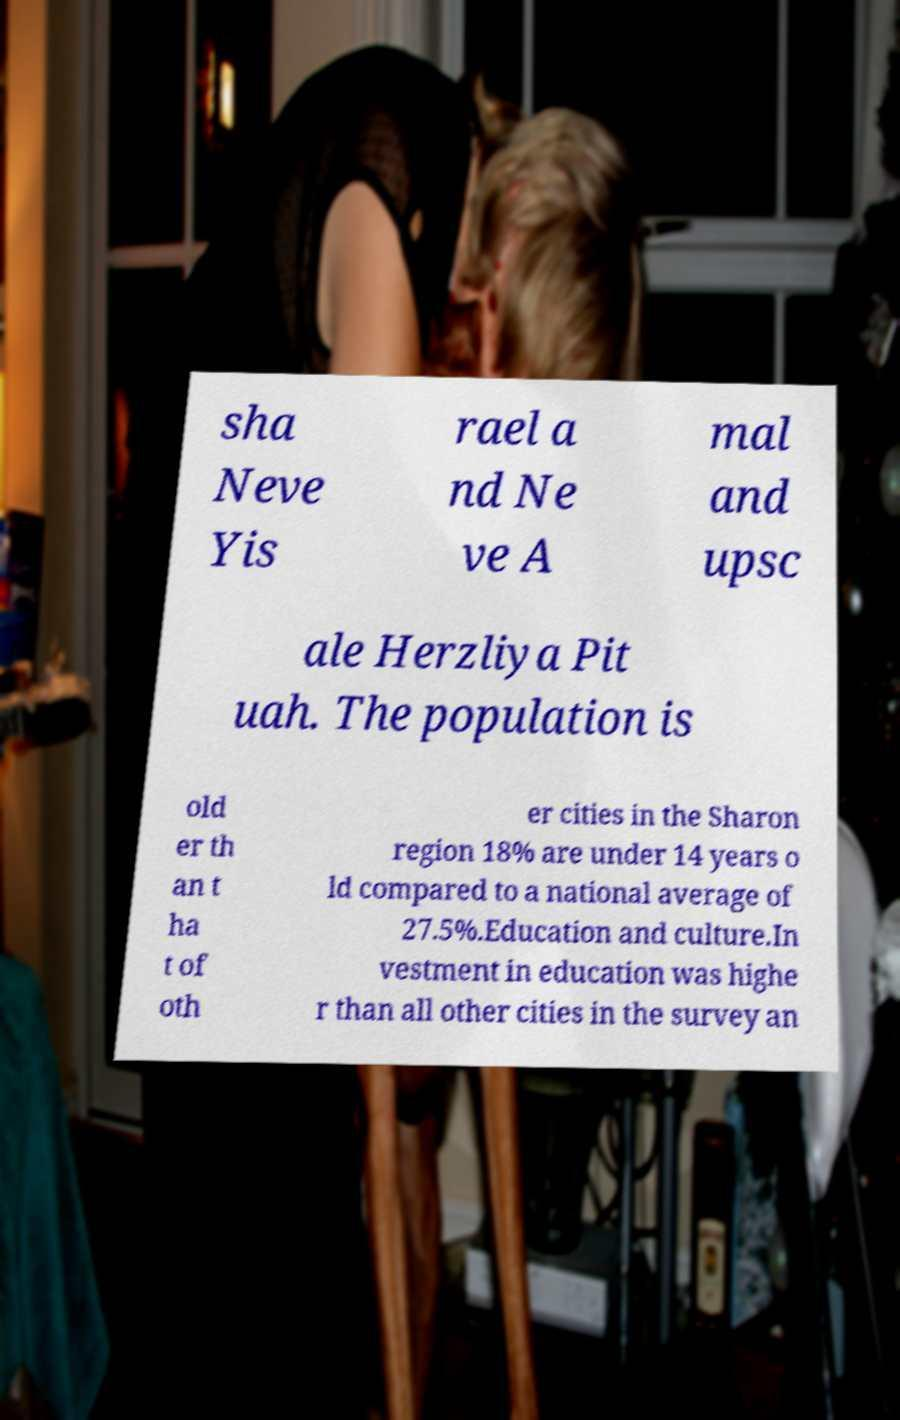Could you assist in decoding the text presented in this image and type it out clearly? sha Neve Yis rael a nd Ne ve A mal and upsc ale Herzliya Pit uah. The population is old er th an t ha t of oth er cities in the Sharon region 18% are under 14 years o ld compared to a national average of 27.5%.Education and culture.In vestment in education was highe r than all other cities in the survey an 